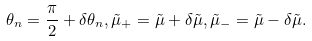Convert formula to latex. <formula><loc_0><loc_0><loc_500><loc_500>\theta _ { n } = \frac { \pi } { 2 } + \delta \theta _ { n } , \tilde { \mu } _ { + } = \tilde { \mu } + \delta \tilde { \mu } , \tilde { \mu } _ { - } = \tilde { \mu } - \delta \tilde { \mu } .</formula> 